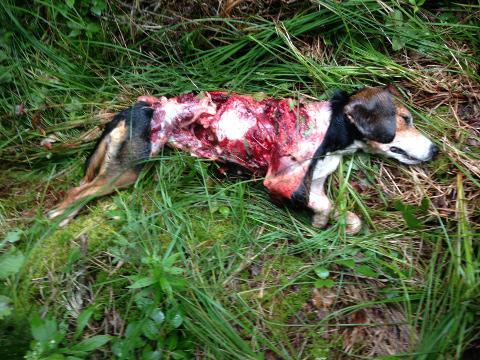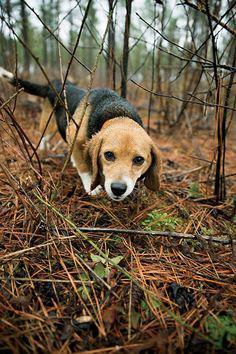The first image is the image on the left, the second image is the image on the right. Analyze the images presented: Is the assertion "A bloody carcass lies in the grass in one image." valid? Answer yes or no. Yes. 